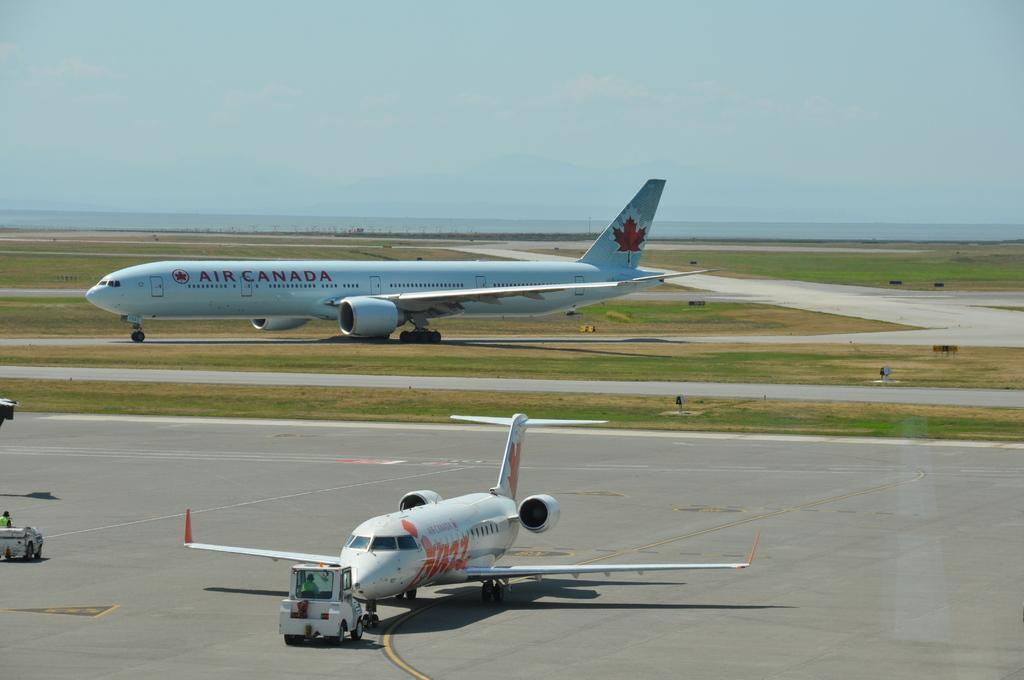In one or two sentences, can you explain what this image depicts? In the center of the image we can see two airplanes and two vehicles. On the airplanes, we can see some text. In the vehicle, we can see two persons are sitting. On the left side of the image, we can see one object. In the background we can see the sky, clouds, grass, poles and a few other objects. 